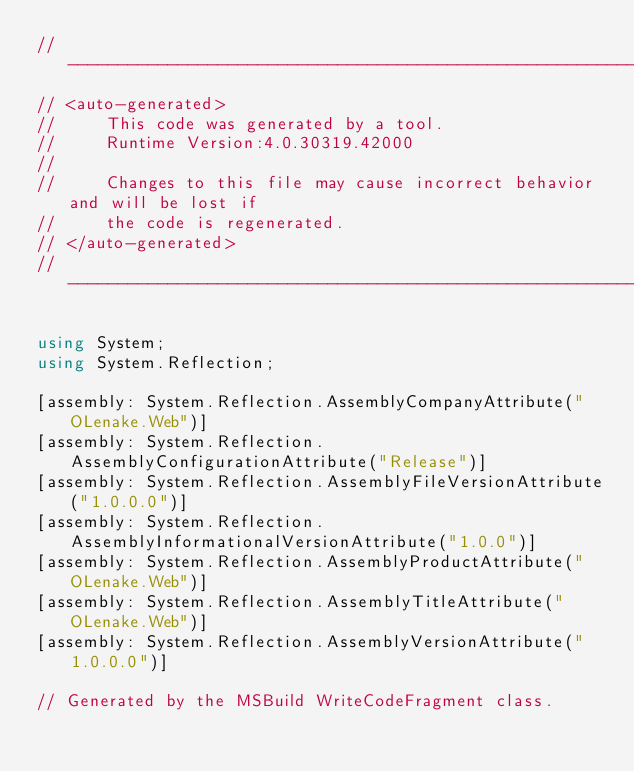<code> <loc_0><loc_0><loc_500><loc_500><_C#_>//------------------------------------------------------------------------------
// <auto-generated>
//     This code was generated by a tool.
//     Runtime Version:4.0.30319.42000
//
//     Changes to this file may cause incorrect behavior and will be lost if
//     the code is regenerated.
// </auto-generated>
//------------------------------------------------------------------------------

using System;
using System.Reflection;

[assembly: System.Reflection.AssemblyCompanyAttribute("OLenake.Web")]
[assembly: System.Reflection.AssemblyConfigurationAttribute("Release")]
[assembly: System.Reflection.AssemblyFileVersionAttribute("1.0.0.0")]
[assembly: System.Reflection.AssemblyInformationalVersionAttribute("1.0.0")]
[assembly: System.Reflection.AssemblyProductAttribute("OLenake.Web")]
[assembly: System.Reflection.AssemblyTitleAttribute("OLenake.Web")]
[assembly: System.Reflection.AssemblyVersionAttribute("1.0.0.0")]

// Generated by the MSBuild WriteCodeFragment class.

</code> 